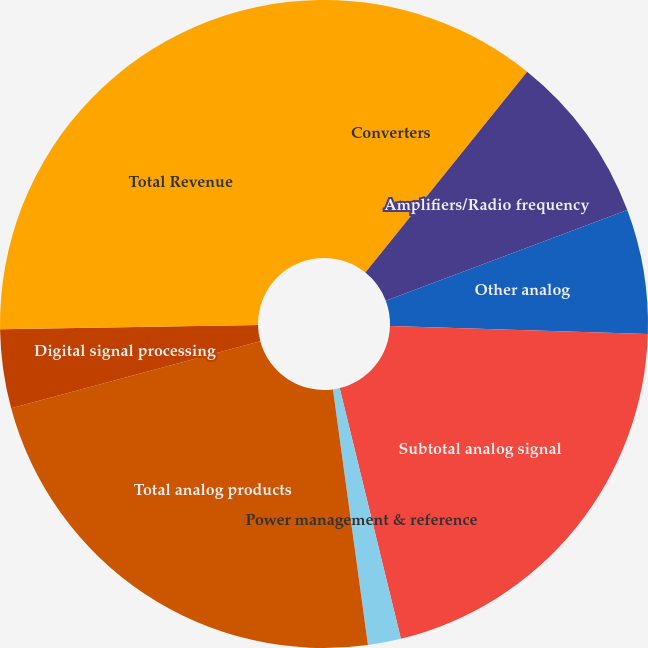Convert chart. <chart><loc_0><loc_0><loc_500><loc_500><pie_chart><fcel>Converters<fcel>Amplifiers/Radio frequency<fcel>Other analog<fcel>Subtotal analog signal<fcel>Power management & reference<fcel>Total analog products<fcel>Digital signal processing<fcel>Total Revenue<nl><fcel>10.79%<fcel>8.49%<fcel>6.21%<fcel>20.7%<fcel>1.65%<fcel>22.98%<fcel>3.93%<fcel>25.26%<nl></chart> 